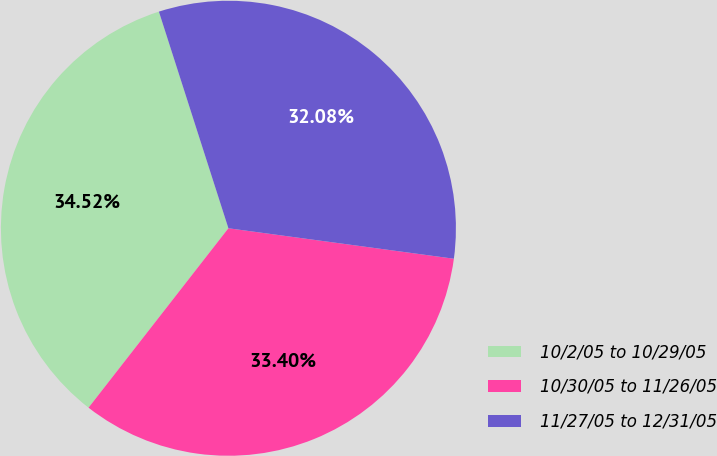<chart> <loc_0><loc_0><loc_500><loc_500><pie_chart><fcel>10/2/05 to 10/29/05<fcel>10/30/05 to 11/26/05<fcel>11/27/05 to 12/31/05<nl><fcel>34.52%<fcel>33.4%<fcel>32.08%<nl></chart> 